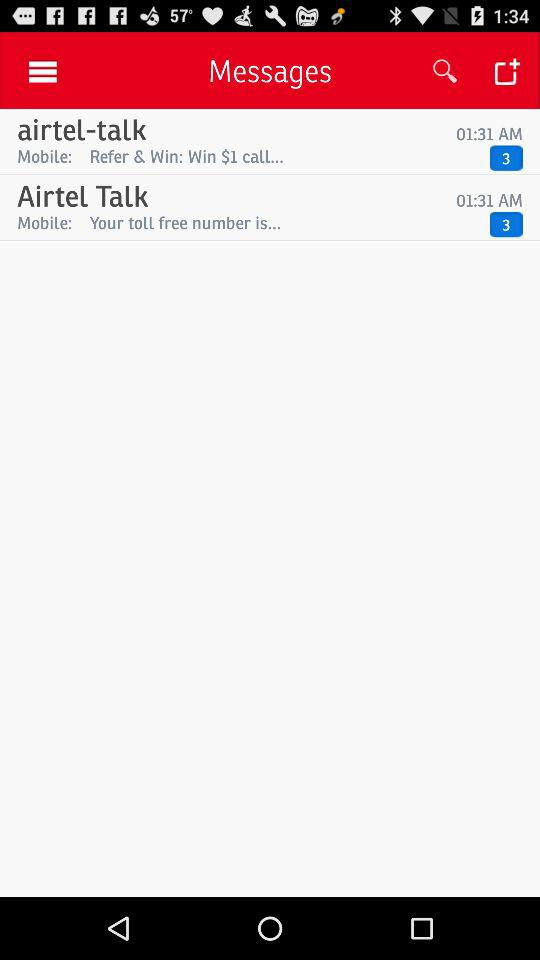What is the time of the last message received from "Airtel Talk"? The time of the last message received from "Airtel Talk" is 1:31 AM. 